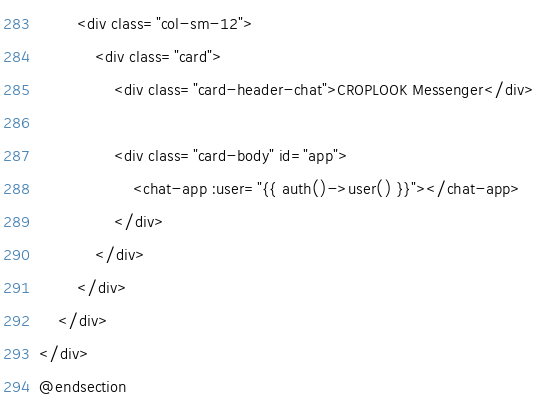<code> <loc_0><loc_0><loc_500><loc_500><_PHP_>        <div class="col-sm-12">
            <div class="card">
                <div class="card-header-chat">CROPLOOK Messenger</div>

                <div class="card-body" id="app">
                    <chat-app :user="{{ auth()->user() }}"></chat-app>
                </div>
            </div>
        </div>
    </div>
</div>
@endsection
</code> 